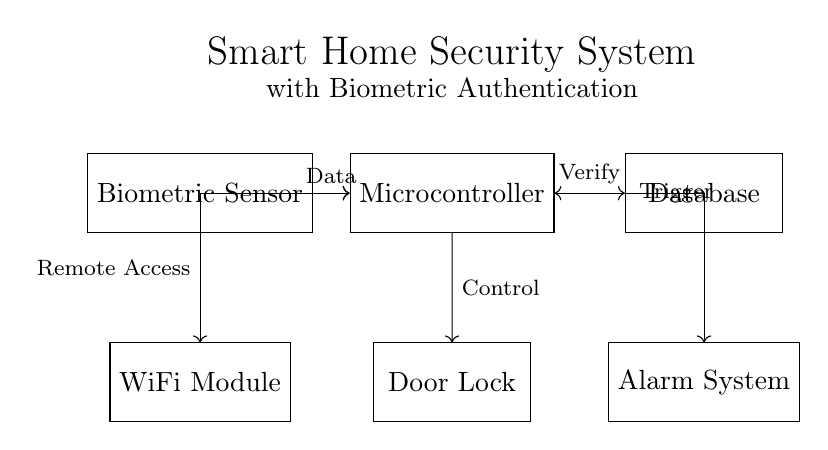What component detects biometric data? The component that detects biometric data is labeled as "Biometric Sensor." It is the first element in the circuit and is connected to the microcontroller.
Answer: Biometric Sensor What does the microcontroller control? The microcontroller, defined in the circuit, sends control signals to the "Door Lock." This indicates its role in managing the access mechanism based on the biometric input.
Answer: Door Lock How does the system enable remote access? The circuit shows that the microcontroller is connected to a "WiFi Module." This connection allows for remote control and access to the smart home security system through the internet.
Answer: WiFi Module What does the alarm system do? The alarm system is triggered by the microcontroller upon verification failure or unauthorized access, as indicated by the directional connection. It acts as a security measure to alert users of potential breaches.
Answer: Trigger What connects the microcontroller and the database for verification purposes? The connection between the microcontroller and the database is bidirectional, denoted by a double-headed arrow. This indicates that data can flow both ways for verification tasks.
Answer: Verify How many main components are there in the circuit? The circuit has five main components: Biometric Sensor, Microcontroller, Database, Door Lock, and Alarm System, which interact to create the whole system.
Answer: Five 